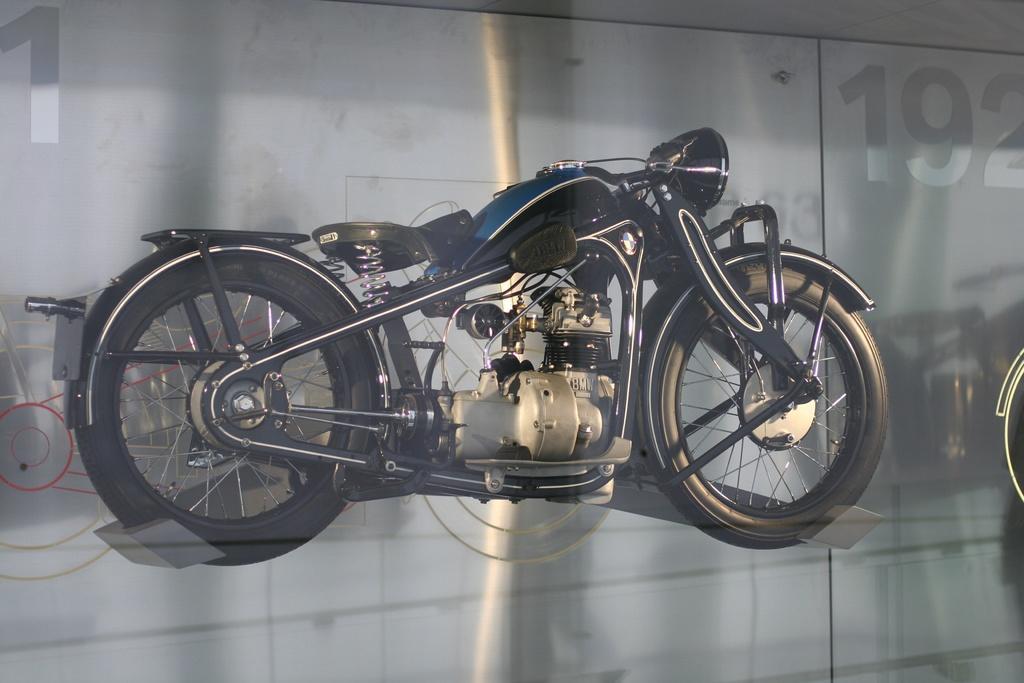In one or two sentences, can you explain what this image depicts? In the center of the picture there is a bike, behind the bike it is glass. On the right there is a number. 